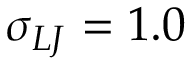Convert formula to latex. <formula><loc_0><loc_0><loc_500><loc_500>\sigma _ { L J } = 1 . 0</formula> 